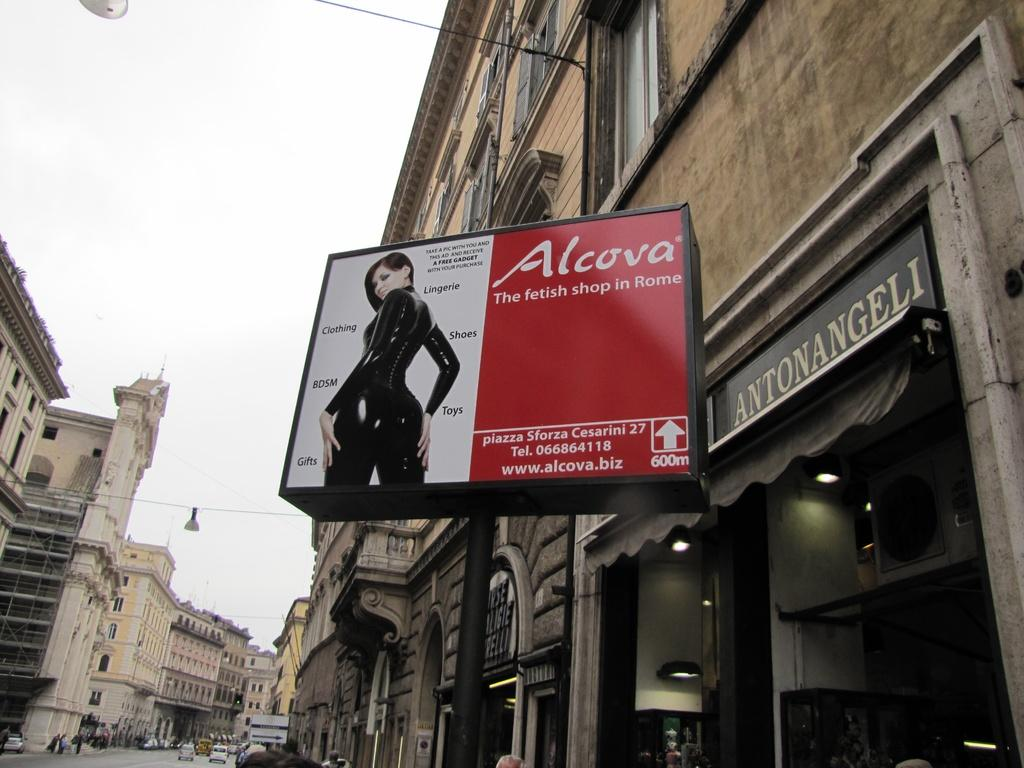<image>
Create a compact narrative representing the image presented. The shop sells many items including gifts, toys and shoes. 